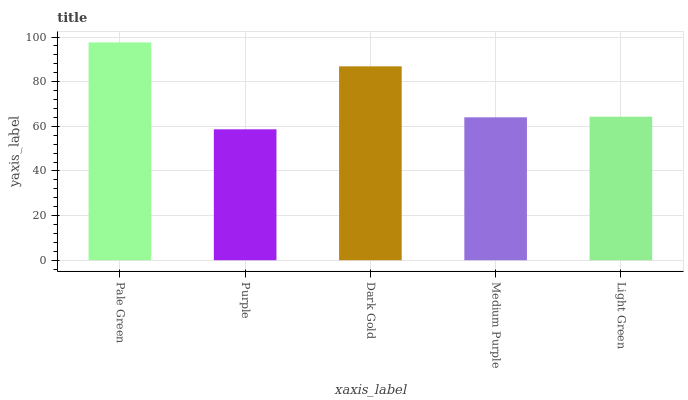Is Dark Gold the minimum?
Answer yes or no. No. Is Dark Gold the maximum?
Answer yes or no. No. Is Dark Gold greater than Purple?
Answer yes or no. Yes. Is Purple less than Dark Gold?
Answer yes or no. Yes. Is Purple greater than Dark Gold?
Answer yes or no. No. Is Dark Gold less than Purple?
Answer yes or no. No. Is Light Green the high median?
Answer yes or no. Yes. Is Light Green the low median?
Answer yes or no. Yes. Is Purple the high median?
Answer yes or no. No. Is Pale Green the low median?
Answer yes or no. No. 